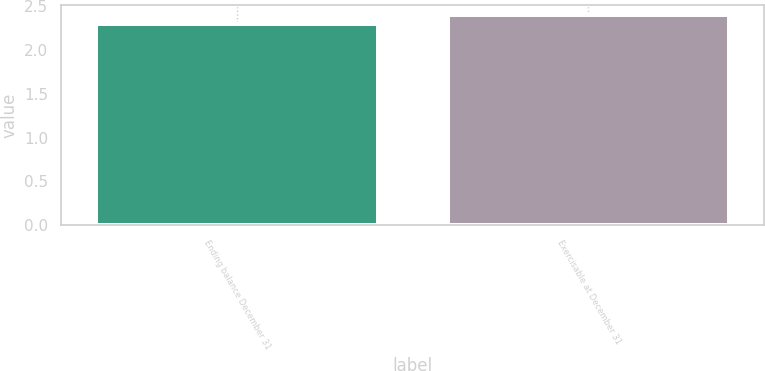Convert chart to OTSL. <chart><loc_0><loc_0><loc_500><loc_500><bar_chart><fcel>Ending balance December 31<fcel>Exercisable at December 31<nl><fcel>2.3<fcel>2.4<nl></chart> 